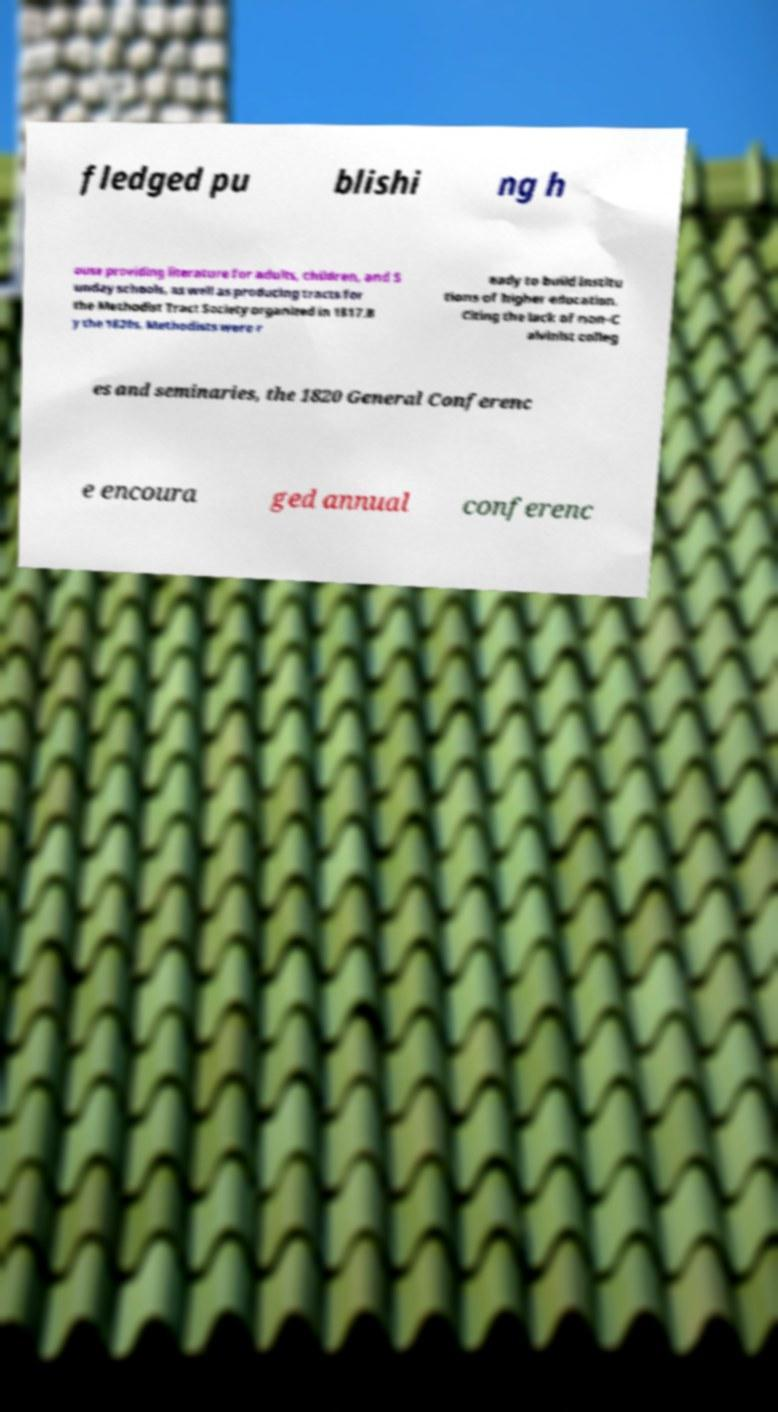Can you read and provide the text displayed in the image?This photo seems to have some interesting text. Can you extract and type it out for me? fledged pu blishi ng h ouse providing literature for adults, children, and S unday schools, as well as producing tracts for the Methodist Tract Society organized in 1817.B y the 1820s, Methodists were r eady to build institu tions of higher education. Citing the lack of non-C alvinist colleg es and seminaries, the 1820 General Conferenc e encoura ged annual conferenc 